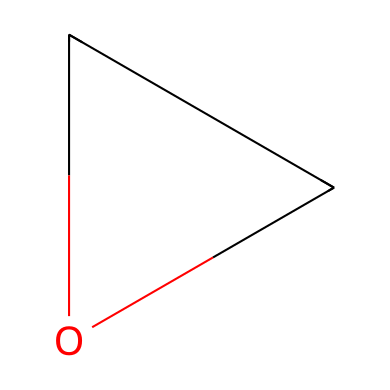How many carbon atoms are in ethylene oxide? The chemical structure indicates one carbon atom directly bonded in the cyclic formation. Counting the carbon atoms shows a total of one.
Answer: one How many oxygen atoms are present in the structure? Looking at the SMILES representation, there is one oxygen atom included in the cyclic structure, specifically between the two carbon atoms.
Answer: one What is the key functional group in ethylene oxide? The cyclic ether structure indicated by the arrangement of carbon and oxygen atoms identifies the presence of an ether functional group within the compound.
Answer: ether What type of bond connects the carbon atoms in ethylene oxide? The arrangement reveals that the carbon atoms are connected by a single bond, as no double or triple bonds are depicted in the SMILES notation.
Answer: single bond What is the state of ethylene oxide at room temperature? Ethylene oxide is a gas at room temperature based on its physical properties and typical behavior of small cyclic ethers which often exist as gases or volatile liquids.
Answer: gas How many total atoms are in the structure of ethylene oxide? By counting both the carbon (1) and oxygen (1), the total number of atoms in the structure adds up to two.
Answer: two 